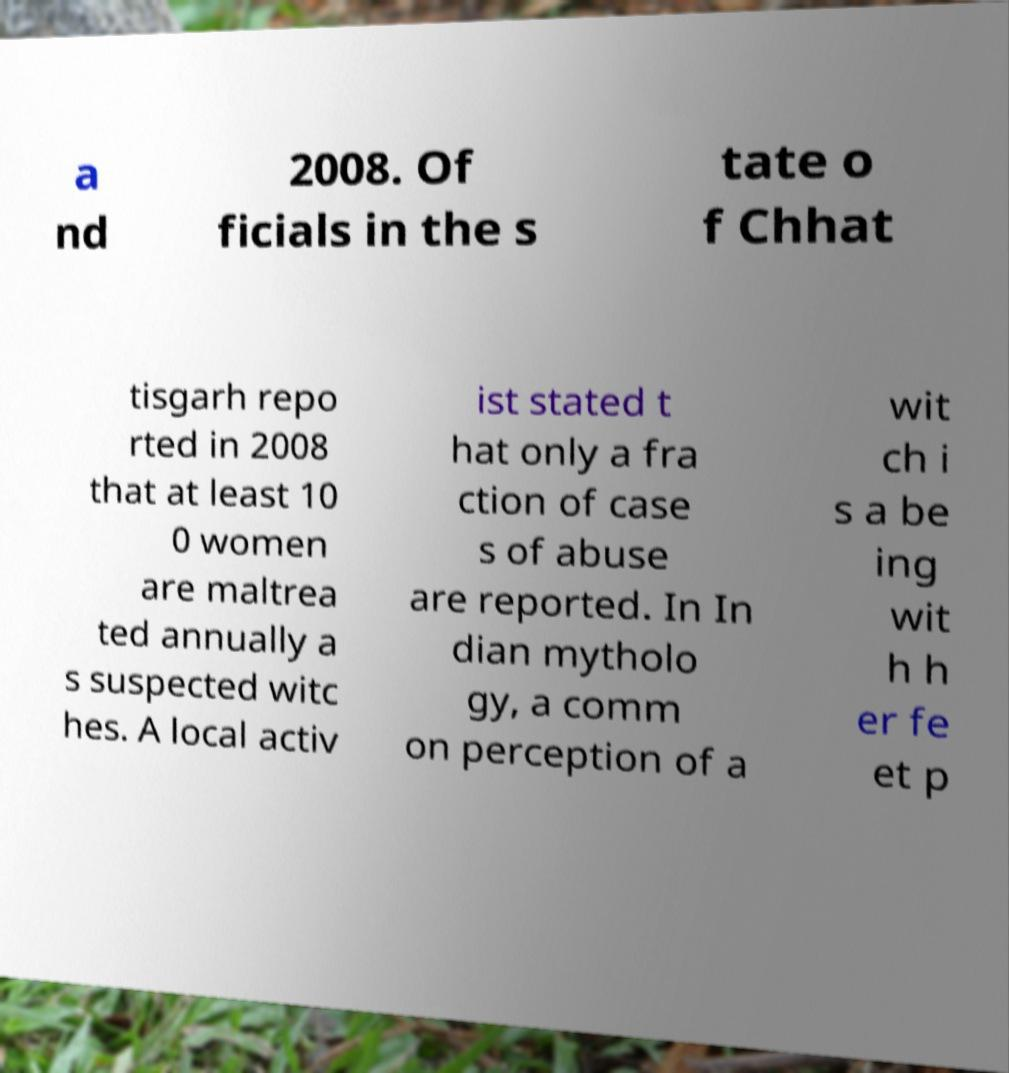There's text embedded in this image that I need extracted. Can you transcribe it verbatim? a nd 2008. Of ficials in the s tate o f Chhat tisgarh repo rted in 2008 that at least 10 0 women are maltrea ted annually a s suspected witc hes. A local activ ist stated t hat only a fra ction of case s of abuse are reported. In In dian mytholo gy, a comm on perception of a wit ch i s a be ing wit h h er fe et p 